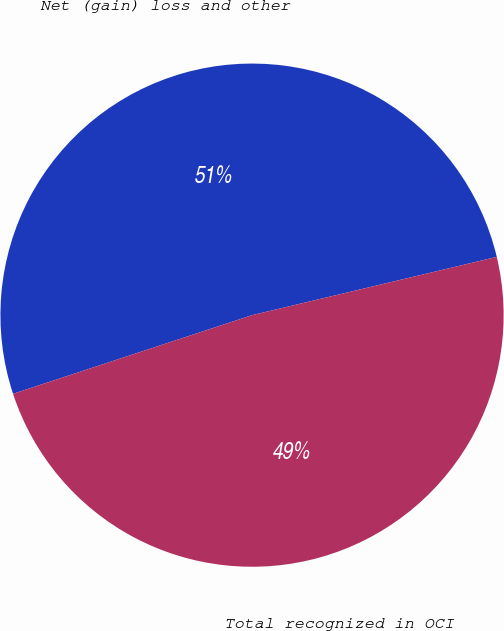<chart> <loc_0><loc_0><loc_500><loc_500><pie_chart><fcel>Net (gain) loss and other<fcel>Total recognized in OCI<nl><fcel>51.34%<fcel>48.66%<nl></chart> 